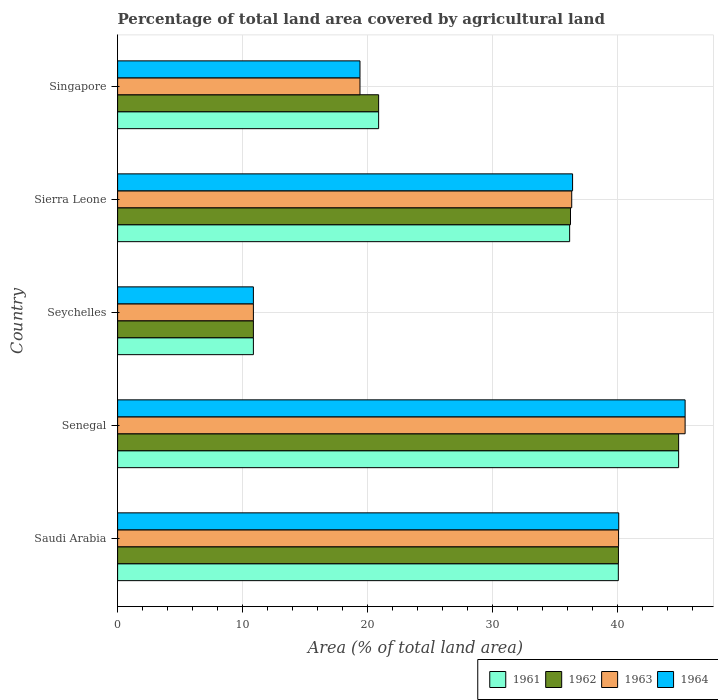How many different coloured bars are there?
Keep it short and to the point. 4. How many groups of bars are there?
Offer a terse response. 5. How many bars are there on the 2nd tick from the top?
Give a very brief answer. 4. How many bars are there on the 1st tick from the bottom?
Make the answer very short. 4. What is the label of the 5th group of bars from the top?
Provide a succinct answer. Saudi Arabia. In how many cases, is the number of bars for a given country not equal to the number of legend labels?
Give a very brief answer. 0. What is the percentage of agricultural land in 1961 in Senegal?
Keep it short and to the point. 44.91. Across all countries, what is the maximum percentage of agricultural land in 1964?
Keep it short and to the point. 45.43. Across all countries, what is the minimum percentage of agricultural land in 1964?
Ensure brevity in your answer.  10.87. In which country was the percentage of agricultural land in 1962 maximum?
Keep it short and to the point. Senegal. In which country was the percentage of agricultural land in 1964 minimum?
Offer a very short reply. Seychelles. What is the total percentage of agricultural land in 1962 in the graph?
Your response must be concise. 153.03. What is the difference between the percentage of agricultural land in 1962 in Seychelles and that in Sierra Leone?
Make the answer very short. -25.39. What is the difference between the percentage of agricultural land in 1964 in Senegal and the percentage of agricultural land in 1962 in Singapore?
Provide a short and direct response. 24.54. What is the average percentage of agricultural land in 1962 per country?
Keep it short and to the point. 30.61. What is the difference between the percentage of agricultural land in 1964 and percentage of agricultural land in 1963 in Saudi Arabia?
Provide a succinct answer. 0.01. In how many countries, is the percentage of agricultural land in 1962 greater than 2 %?
Make the answer very short. 5. What is the ratio of the percentage of agricultural land in 1962 in Seychelles to that in Singapore?
Keep it short and to the point. 0.52. Is the difference between the percentage of agricultural land in 1964 in Seychelles and Sierra Leone greater than the difference between the percentage of agricultural land in 1963 in Seychelles and Sierra Leone?
Make the answer very short. No. What is the difference between the highest and the second highest percentage of agricultural land in 1961?
Ensure brevity in your answer.  4.83. What is the difference between the highest and the lowest percentage of agricultural land in 1961?
Give a very brief answer. 34.04. Is the sum of the percentage of agricultural land in 1964 in Seychelles and Sierra Leone greater than the maximum percentage of agricultural land in 1963 across all countries?
Your answer should be compact. Yes. Is it the case that in every country, the sum of the percentage of agricultural land in 1964 and percentage of agricultural land in 1963 is greater than the sum of percentage of agricultural land in 1961 and percentage of agricultural land in 1962?
Offer a terse response. No. What does the 1st bar from the top in Sierra Leone represents?
Ensure brevity in your answer.  1964. How many bars are there?
Provide a succinct answer. 20. Are all the bars in the graph horizontal?
Your answer should be compact. Yes. How many countries are there in the graph?
Provide a succinct answer. 5. Are the values on the major ticks of X-axis written in scientific E-notation?
Ensure brevity in your answer.  No. Does the graph contain grids?
Ensure brevity in your answer.  Yes. What is the title of the graph?
Your answer should be very brief. Percentage of total land area covered by agricultural land. Does "1970" appear as one of the legend labels in the graph?
Your answer should be compact. No. What is the label or title of the X-axis?
Your answer should be compact. Area (% of total land area). What is the label or title of the Y-axis?
Make the answer very short. Country. What is the Area (% of total land area) in 1961 in Saudi Arabia?
Make the answer very short. 40.08. What is the Area (% of total land area) in 1962 in Saudi Arabia?
Make the answer very short. 40.09. What is the Area (% of total land area) of 1963 in Saudi Arabia?
Give a very brief answer. 40.1. What is the Area (% of total land area) in 1964 in Saudi Arabia?
Your response must be concise. 40.12. What is the Area (% of total land area) of 1961 in Senegal?
Keep it short and to the point. 44.91. What is the Area (% of total land area) in 1962 in Senegal?
Your answer should be very brief. 44.91. What is the Area (% of total land area) of 1963 in Senegal?
Your answer should be compact. 45.43. What is the Area (% of total land area) in 1964 in Senegal?
Offer a very short reply. 45.43. What is the Area (% of total land area) in 1961 in Seychelles?
Provide a short and direct response. 10.87. What is the Area (% of total land area) in 1962 in Seychelles?
Provide a succinct answer. 10.87. What is the Area (% of total land area) in 1963 in Seychelles?
Your answer should be compact. 10.87. What is the Area (% of total land area) of 1964 in Seychelles?
Provide a short and direct response. 10.87. What is the Area (% of total land area) in 1961 in Sierra Leone?
Your answer should be compact. 36.19. What is the Area (% of total land area) in 1962 in Sierra Leone?
Your response must be concise. 36.26. What is the Area (% of total land area) in 1963 in Sierra Leone?
Your answer should be very brief. 36.35. What is the Area (% of total land area) of 1964 in Sierra Leone?
Your response must be concise. 36.42. What is the Area (% of total land area) in 1961 in Singapore?
Give a very brief answer. 20.9. What is the Area (% of total land area) in 1962 in Singapore?
Ensure brevity in your answer.  20.9. What is the Area (% of total land area) of 1963 in Singapore?
Provide a short and direct response. 19.4. What is the Area (% of total land area) in 1964 in Singapore?
Provide a short and direct response. 19.4. Across all countries, what is the maximum Area (% of total land area) in 1961?
Provide a succinct answer. 44.91. Across all countries, what is the maximum Area (% of total land area) of 1962?
Make the answer very short. 44.91. Across all countries, what is the maximum Area (% of total land area) in 1963?
Your answer should be compact. 45.43. Across all countries, what is the maximum Area (% of total land area) of 1964?
Offer a very short reply. 45.43. Across all countries, what is the minimum Area (% of total land area) of 1961?
Keep it short and to the point. 10.87. Across all countries, what is the minimum Area (% of total land area) in 1962?
Provide a short and direct response. 10.87. Across all countries, what is the minimum Area (% of total land area) of 1963?
Ensure brevity in your answer.  10.87. Across all countries, what is the minimum Area (% of total land area) in 1964?
Make the answer very short. 10.87. What is the total Area (% of total land area) in 1961 in the graph?
Offer a very short reply. 152.95. What is the total Area (% of total land area) of 1962 in the graph?
Your answer should be compact. 153.03. What is the total Area (% of total land area) in 1963 in the graph?
Provide a short and direct response. 152.16. What is the total Area (% of total land area) in 1964 in the graph?
Offer a very short reply. 152.25. What is the difference between the Area (% of total land area) in 1961 in Saudi Arabia and that in Senegal?
Make the answer very short. -4.83. What is the difference between the Area (% of total land area) in 1962 in Saudi Arabia and that in Senegal?
Give a very brief answer. -4.82. What is the difference between the Area (% of total land area) in 1963 in Saudi Arabia and that in Senegal?
Offer a terse response. -5.33. What is the difference between the Area (% of total land area) in 1964 in Saudi Arabia and that in Senegal?
Provide a short and direct response. -5.31. What is the difference between the Area (% of total land area) of 1961 in Saudi Arabia and that in Seychelles?
Provide a succinct answer. 29.22. What is the difference between the Area (% of total land area) in 1962 in Saudi Arabia and that in Seychelles?
Provide a succinct answer. 29.22. What is the difference between the Area (% of total land area) of 1963 in Saudi Arabia and that in Seychelles?
Your response must be concise. 29.23. What is the difference between the Area (% of total land area) of 1964 in Saudi Arabia and that in Seychelles?
Offer a terse response. 29.25. What is the difference between the Area (% of total land area) in 1961 in Saudi Arabia and that in Sierra Leone?
Your response must be concise. 3.9. What is the difference between the Area (% of total land area) of 1962 in Saudi Arabia and that in Sierra Leone?
Provide a short and direct response. 3.84. What is the difference between the Area (% of total land area) of 1963 in Saudi Arabia and that in Sierra Leone?
Make the answer very short. 3.75. What is the difference between the Area (% of total land area) of 1964 in Saudi Arabia and that in Sierra Leone?
Your answer should be compact. 3.69. What is the difference between the Area (% of total land area) of 1961 in Saudi Arabia and that in Singapore?
Offer a very short reply. 19.19. What is the difference between the Area (% of total land area) of 1962 in Saudi Arabia and that in Singapore?
Ensure brevity in your answer.  19.2. What is the difference between the Area (% of total land area) of 1963 in Saudi Arabia and that in Singapore?
Make the answer very short. 20.7. What is the difference between the Area (% of total land area) of 1964 in Saudi Arabia and that in Singapore?
Offer a very short reply. 20.71. What is the difference between the Area (% of total land area) of 1961 in Senegal and that in Seychelles?
Provide a succinct answer. 34.04. What is the difference between the Area (% of total land area) in 1962 in Senegal and that in Seychelles?
Your answer should be compact. 34.04. What is the difference between the Area (% of total land area) of 1963 in Senegal and that in Seychelles?
Your answer should be compact. 34.56. What is the difference between the Area (% of total land area) in 1964 in Senegal and that in Seychelles?
Give a very brief answer. 34.56. What is the difference between the Area (% of total land area) of 1961 in Senegal and that in Sierra Leone?
Your answer should be compact. 8.73. What is the difference between the Area (% of total land area) in 1962 in Senegal and that in Sierra Leone?
Make the answer very short. 8.66. What is the difference between the Area (% of total land area) in 1963 in Senegal and that in Sierra Leone?
Provide a short and direct response. 9.08. What is the difference between the Area (% of total land area) in 1964 in Senegal and that in Sierra Leone?
Offer a very short reply. 9.01. What is the difference between the Area (% of total land area) of 1961 in Senegal and that in Singapore?
Your response must be concise. 24.02. What is the difference between the Area (% of total land area) in 1962 in Senegal and that in Singapore?
Offer a terse response. 24.02. What is the difference between the Area (% of total land area) in 1963 in Senegal and that in Singapore?
Your answer should be compact. 26.03. What is the difference between the Area (% of total land area) in 1964 in Senegal and that in Singapore?
Give a very brief answer. 26.03. What is the difference between the Area (% of total land area) in 1961 in Seychelles and that in Sierra Leone?
Your answer should be very brief. -25.32. What is the difference between the Area (% of total land area) of 1962 in Seychelles and that in Sierra Leone?
Your answer should be very brief. -25.39. What is the difference between the Area (% of total land area) of 1963 in Seychelles and that in Sierra Leone?
Keep it short and to the point. -25.48. What is the difference between the Area (% of total land area) of 1964 in Seychelles and that in Sierra Leone?
Keep it short and to the point. -25.55. What is the difference between the Area (% of total land area) of 1961 in Seychelles and that in Singapore?
Offer a terse response. -10.03. What is the difference between the Area (% of total land area) of 1962 in Seychelles and that in Singapore?
Your answer should be compact. -10.03. What is the difference between the Area (% of total land area) in 1963 in Seychelles and that in Singapore?
Offer a very short reply. -8.53. What is the difference between the Area (% of total land area) of 1964 in Seychelles and that in Singapore?
Ensure brevity in your answer.  -8.53. What is the difference between the Area (% of total land area) in 1961 in Sierra Leone and that in Singapore?
Keep it short and to the point. 15.29. What is the difference between the Area (% of total land area) of 1962 in Sierra Leone and that in Singapore?
Provide a short and direct response. 15.36. What is the difference between the Area (% of total land area) in 1963 in Sierra Leone and that in Singapore?
Give a very brief answer. 16.95. What is the difference between the Area (% of total land area) of 1964 in Sierra Leone and that in Singapore?
Provide a short and direct response. 17.02. What is the difference between the Area (% of total land area) of 1961 in Saudi Arabia and the Area (% of total land area) of 1962 in Senegal?
Your response must be concise. -4.83. What is the difference between the Area (% of total land area) in 1961 in Saudi Arabia and the Area (% of total land area) in 1963 in Senegal?
Your answer should be very brief. -5.35. What is the difference between the Area (% of total land area) of 1961 in Saudi Arabia and the Area (% of total land area) of 1964 in Senegal?
Keep it short and to the point. -5.35. What is the difference between the Area (% of total land area) of 1962 in Saudi Arabia and the Area (% of total land area) of 1963 in Senegal?
Your answer should be compact. -5.34. What is the difference between the Area (% of total land area) in 1962 in Saudi Arabia and the Area (% of total land area) in 1964 in Senegal?
Your response must be concise. -5.34. What is the difference between the Area (% of total land area) of 1963 in Saudi Arabia and the Area (% of total land area) of 1964 in Senegal?
Ensure brevity in your answer.  -5.33. What is the difference between the Area (% of total land area) of 1961 in Saudi Arabia and the Area (% of total land area) of 1962 in Seychelles?
Your answer should be very brief. 29.22. What is the difference between the Area (% of total land area) in 1961 in Saudi Arabia and the Area (% of total land area) in 1963 in Seychelles?
Your answer should be compact. 29.22. What is the difference between the Area (% of total land area) in 1961 in Saudi Arabia and the Area (% of total land area) in 1964 in Seychelles?
Offer a very short reply. 29.22. What is the difference between the Area (% of total land area) of 1962 in Saudi Arabia and the Area (% of total land area) of 1963 in Seychelles?
Your response must be concise. 29.22. What is the difference between the Area (% of total land area) in 1962 in Saudi Arabia and the Area (% of total land area) in 1964 in Seychelles?
Give a very brief answer. 29.22. What is the difference between the Area (% of total land area) of 1963 in Saudi Arabia and the Area (% of total land area) of 1964 in Seychelles?
Give a very brief answer. 29.23. What is the difference between the Area (% of total land area) in 1961 in Saudi Arabia and the Area (% of total land area) in 1962 in Sierra Leone?
Your answer should be compact. 3.83. What is the difference between the Area (% of total land area) in 1961 in Saudi Arabia and the Area (% of total land area) in 1963 in Sierra Leone?
Give a very brief answer. 3.73. What is the difference between the Area (% of total land area) in 1961 in Saudi Arabia and the Area (% of total land area) in 1964 in Sierra Leone?
Your answer should be very brief. 3.66. What is the difference between the Area (% of total land area) in 1962 in Saudi Arabia and the Area (% of total land area) in 1963 in Sierra Leone?
Ensure brevity in your answer.  3.74. What is the difference between the Area (% of total land area) of 1962 in Saudi Arabia and the Area (% of total land area) of 1964 in Sierra Leone?
Ensure brevity in your answer.  3.67. What is the difference between the Area (% of total land area) in 1963 in Saudi Arabia and the Area (% of total land area) in 1964 in Sierra Leone?
Offer a terse response. 3.68. What is the difference between the Area (% of total land area) of 1961 in Saudi Arabia and the Area (% of total land area) of 1962 in Singapore?
Your answer should be compact. 19.19. What is the difference between the Area (% of total land area) of 1961 in Saudi Arabia and the Area (% of total land area) of 1963 in Singapore?
Keep it short and to the point. 20.68. What is the difference between the Area (% of total land area) of 1961 in Saudi Arabia and the Area (% of total land area) of 1964 in Singapore?
Provide a succinct answer. 20.68. What is the difference between the Area (% of total land area) in 1962 in Saudi Arabia and the Area (% of total land area) in 1963 in Singapore?
Provide a succinct answer. 20.69. What is the difference between the Area (% of total land area) in 1962 in Saudi Arabia and the Area (% of total land area) in 1964 in Singapore?
Make the answer very short. 20.69. What is the difference between the Area (% of total land area) of 1963 in Saudi Arabia and the Area (% of total land area) of 1964 in Singapore?
Your response must be concise. 20.7. What is the difference between the Area (% of total land area) of 1961 in Senegal and the Area (% of total land area) of 1962 in Seychelles?
Provide a short and direct response. 34.04. What is the difference between the Area (% of total land area) in 1961 in Senegal and the Area (% of total land area) in 1963 in Seychelles?
Ensure brevity in your answer.  34.04. What is the difference between the Area (% of total land area) in 1961 in Senegal and the Area (% of total land area) in 1964 in Seychelles?
Your response must be concise. 34.04. What is the difference between the Area (% of total land area) in 1962 in Senegal and the Area (% of total land area) in 1963 in Seychelles?
Keep it short and to the point. 34.04. What is the difference between the Area (% of total land area) of 1962 in Senegal and the Area (% of total land area) of 1964 in Seychelles?
Make the answer very short. 34.04. What is the difference between the Area (% of total land area) in 1963 in Senegal and the Area (% of total land area) in 1964 in Seychelles?
Your answer should be compact. 34.56. What is the difference between the Area (% of total land area) in 1961 in Senegal and the Area (% of total land area) in 1962 in Sierra Leone?
Provide a succinct answer. 8.66. What is the difference between the Area (% of total land area) in 1961 in Senegal and the Area (% of total land area) in 1963 in Sierra Leone?
Your answer should be compact. 8.56. What is the difference between the Area (% of total land area) of 1961 in Senegal and the Area (% of total land area) of 1964 in Sierra Leone?
Your response must be concise. 8.49. What is the difference between the Area (% of total land area) of 1962 in Senegal and the Area (% of total land area) of 1963 in Sierra Leone?
Your answer should be very brief. 8.56. What is the difference between the Area (% of total land area) of 1962 in Senegal and the Area (% of total land area) of 1964 in Sierra Leone?
Keep it short and to the point. 8.49. What is the difference between the Area (% of total land area) of 1963 in Senegal and the Area (% of total land area) of 1964 in Sierra Leone?
Your answer should be compact. 9.01. What is the difference between the Area (% of total land area) of 1961 in Senegal and the Area (% of total land area) of 1962 in Singapore?
Offer a very short reply. 24.02. What is the difference between the Area (% of total land area) in 1961 in Senegal and the Area (% of total land area) in 1963 in Singapore?
Ensure brevity in your answer.  25.51. What is the difference between the Area (% of total land area) of 1961 in Senegal and the Area (% of total land area) of 1964 in Singapore?
Offer a terse response. 25.51. What is the difference between the Area (% of total land area) of 1962 in Senegal and the Area (% of total land area) of 1963 in Singapore?
Provide a short and direct response. 25.51. What is the difference between the Area (% of total land area) of 1962 in Senegal and the Area (% of total land area) of 1964 in Singapore?
Provide a succinct answer. 25.51. What is the difference between the Area (% of total land area) in 1963 in Senegal and the Area (% of total land area) in 1964 in Singapore?
Provide a short and direct response. 26.03. What is the difference between the Area (% of total land area) of 1961 in Seychelles and the Area (% of total land area) of 1962 in Sierra Leone?
Your response must be concise. -25.39. What is the difference between the Area (% of total land area) of 1961 in Seychelles and the Area (% of total land area) of 1963 in Sierra Leone?
Provide a succinct answer. -25.48. What is the difference between the Area (% of total land area) of 1961 in Seychelles and the Area (% of total land area) of 1964 in Sierra Leone?
Offer a terse response. -25.55. What is the difference between the Area (% of total land area) in 1962 in Seychelles and the Area (% of total land area) in 1963 in Sierra Leone?
Your response must be concise. -25.48. What is the difference between the Area (% of total land area) in 1962 in Seychelles and the Area (% of total land area) in 1964 in Sierra Leone?
Offer a very short reply. -25.55. What is the difference between the Area (% of total land area) of 1963 in Seychelles and the Area (% of total land area) of 1964 in Sierra Leone?
Your answer should be very brief. -25.55. What is the difference between the Area (% of total land area) in 1961 in Seychelles and the Area (% of total land area) in 1962 in Singapore?
Your answer should be very brief. -10.03. What is the difference between the Area (% of total land area) of 1961 in Seychelles and the Area (% of total land area) of 1963 in Singapore?
Your answer should be very brief. -8.53. What is the difference between the Area (% of total land area) in 1961 in Seychelles and the Area (% of total land area) in 1964 in Singapore?
Keep it short and to the point. -8.53. What is the difference between the Area (% of total land area) in 1962 in Seychelles and the Area (% of total land area) in 1963 in Singapore?
Provide a succinct answer. -8.53. What is the difference between the Area (% of total land area) of 1962 in Seychelles and the Area (% of total land area) of 1964 in Singapore?
Keep it short and to the point. -8.53. What is the difference between the Area (% of total land area) of 1963 in Seychelles and the Area (% of total land area) of 1964 in Singapore?
Make the answer very short. -8.53. What is the difference between the Area (% of total land area) of 1961 in Sierra Leone and the Area (% of total land area) of 1962 in Singapore?
Provide a succinct answer. 15.29. What is the difference between the Area (% of total land area) in 1961 in Sierra Leone and the Area (% of total land area) in 1963 in Singapore?
Provide a short and direct response. 16.78. What is the difference between the Area (% of total land area) in 1961 in Sierra Leone and the Area (% of total land area) in 1964 in Singapore?
Offer a very short reply. 16.78. What is the difference between the Area (% of total land area) in 1962 in Sierra Leone and the Area (% of total land area) in 1963 in Singapore?
Provide a short and direct response. 16.85. What is the difference between the Area (% of total land area) of 1962 in Sierra Leone and the Area (% of total land area) of 1964 in Singapore?
Your answer should be compact. 16.85. What is the difference between the Area (% of total land area) of 1963 in Sierra Leone and the Area (% of total land area) of 1964 in Singapore?
Provide a short and direct response. 16.95. What is the average Area (% of total land area) in 1961 per country?
Provide a short and direct response. 30.59. What is the average Area (% of total land area) of 1962 per country?
Your response must be concise. 30.61. What is the average Area (% of total land area) in 1963 per country?
Make the answer very short. 30.43. What is the average Area (% of total land area) of 1964 per country?
Your answer should be very brief. 30.45. What is the difference between the Area (% of total land area) in 1961 and Area (% of total land area) in 1962 in Saudi Arabia?
Ensure brevity in your answer.  -0.01. What is the difference between the Area (% of total land area) in 1961 and Area (% of total land area) in 1963 in Saudi Arabia?
Your response must be concise. -0.02. What is the difference between the Area (% of total land area) of 1961 and Area (% of total land area) of 1964 in Saudi Arabia?
Provide a succinct answer. -0.03. What is the difference between the Area (% of total land area) of 1962 and Area (% of total land area) of 1963 in Saudi Arabia?
Give a very brief answer. -0.01. What is the difference between the Area (% of total land area) in 1962 and Area (% of total land area) in 1964 in Saudi Arabia?
Give a very brief answer. -0.02. What is the difference between the Area (% of total land area) in 1963 and Area (% of total land area) in 1964 in Saudi Arabia?
Ensure brevity in your answer.  -0.01. What is the difference between the Area (% of total land area) of 1961 and Area (% of total land area) of 1963 in Senegal?
Provide a short and direct response. -0.52. What is the difference between the Area (% of total land area) in 1961 and Area (% of total land area) in 1964 in Senegal?
Make the answer very short. -0.52. What is the difference between the Area (% of total land area) of 1962 and Area (% of total land area) of 1963 in Senegal?
Make the answer very short. -0.52. What is the difference between the Area (% of total land area) of 1962 and Area (% of total land area) of 1964 in Senegal?
Offer a terse response. -0.52. What is the difference between the Area (% of total land area) of 1961 and Area (% of total land area) of 1962 in Seychelles?
Make the answer very short. 0. What is the difference between the Area (% of total land area) of 1962 and Area (% of total land area) of 1963 in Seychelles?
Make the answer very short. 0. What is the difference between the Area (% of total land area) of 1962 and Area (% of total land area) of 1964 in Seychelles?
Provide a short and direct response. 0. What is the difference between the Area (% of total land area) in 1963 and Area (% of total land area) in 1964 in Seychelles?
Your answer should be very brief. 0. What is the difference between the Area (% of total land area) of 1961 and Area (% of total land area) of 1962 in Sierra Leone?
Provide a succinct answer. -0.07. What is the difference between the Area (% of total land area) in 1961 and Area (% of total land area) in 1963 in Sierra Leone?
Ensure brevity in your answer.  -0.17. What is the difference between the Area (% of total land area) of 1961 and Area (% of total land area) of 1964 in Sierra Leone?
Your answer should be very brief. -0.24. What is the difference between the Area (% of total land area) in 1962 and Area (% of total land area) in 1963 in Sierra Leone?
Provide a succinct answer. -0.1. What is the difference between the Area (% of total land area) of 1962 and Area (% of total land area) of 1964 in Sierra Leone?
Make the answer very short. -0.17. What is the difference between the Area (% of total land area) of 1963 and Area (% of total land area) of 1964 in Sierra Leone?
Your answer should be compact. -0.07. What is the difference between the Area (% of total land area) of 1961 and Area (% of total land area) of 1962 in Singapore?
Your answer should be very brief. 0. What is the difference between the Area (% of total land area) of 1961 and Area (% of total land area) of 1963 in Singapore?
Your response must be concise. 1.49. What is the difference between the Area (% of total land area) in 1961 and Area (% of total land area) in 1964 in Singapore?
Offer a terse response. 1.49. What is the difference between the Area (% of total land area) of 1962 and Area (% of total land area) of 1963 in Singapore?
Provide a short and direct response. 1.49. What is the difference between the Area (% of total land area) of 1962 and Area (% of total land area) of 1964 in Singapore?
Provide a short and direct response. 1.49. What is the ratio of the Area (% of total land area) in 1961 in Saudi Arabia to that in Senegal?
Give a very brief answer. 0.89. What is the ratio of the Area (% of total land area) in 1962 in Saudi Arabia to that in Senegal?
Make the answer very short. 0.89. What is the ratio of the Area (% of total land area) in 1963 in Saudi Arabia to that in Senegal?
Keep it short and to the point. 0.88. What is the ratio of the Area (% of total land area) of 1964 in Saudi Arabia to that in Senegal?
Make the answer very short. 0.88. What is the ratio of the Area (% of total land area) in 1961 in Saudi Arabia to that in Seychelles?
Provide a succinct answer. 3.69. What is the ratio of the Area (% of total land area) of 1962 in Saudi Arabia to that in Seychelles?
Provide a succinct answer. 3.69. What is the ratio of the Area (% of total land area) in 1963 in Saudi Arabia to that in Seychelles?
Keep it short and to the point. 3.69. What is the ratio of the Area (% of total land area) in 1964 in Saudi Arabia to that in Seychelles?
Ensure brevity in your answer.  3.69. What is the ratio of the Area (% of total land area) of 1961 in Saudi Arabia to that in Sierra Leone?
Offer a very short reply. 1.11. What is the ratio of the Area (% of total land area) in 1962 in Saudi Arabia to that in Sierra Leone?
Your answer should be very brief. 1.11. What is the ratio of the Area (% of total land area) of 1963 in Saudi Arabia to that in Sierra Leone?
Offer a terse response. 1.1. What is the ratio of the Area (% of total land area) in 1964 in Saudi Arabia to that in Sierra Leone?
Ensure brevity in your answer.  1.1. What is the ratio of the Area (% of total land area) of 1961 in Saudi Arabia to that in Singapore?
Ensure brevity in your answer.  1.92. What is the ratio of the Area (% of total land area) in 1962 in Saudi Arabia to that in Singapore?
Offer a very short reply. 1.92. What is the ratio of the Area (% of total land area) in 1963 in Saudi Arabia to that in Singapore?
Provide a short and direct response. 2.07. What is the ratio of the Area (% of total land area) of 1964 in Saudi Arabia to that in Singapore?
Provide a succinct answer. 2.07. What is the ratio of the Area (% of total land area) in 1961 in Senegal to that in Seychelles?
Keep it short and to the point. 4.13. What is the ratio of the Area (% of total land area) of 1962 in Senegal to that in Seychelles?
Your answer should be very brief. 4.13. What is the ratio of the Area (% of total land area) in 1963 in Senegal to that in Seychelles?
Ensure brevity in your answer.  4.18. What is the ratio of the Area (% of total land area) of 1964 in Senegal to that in Seychelles?
Ensure brevity in your answer.  4.18. What is the ratio of the Area (% of total land area) of 1961 in Senegal to that in Sierra Leone?
Provide a short and direct response. 1.24. What is the ratio of the Area (% of total land area) of 1962 in Senegal to that in Sierra Leone?
Offer a very short reply. 1.24. What is the ratio of the Area (% of total land area) of 1963 in Senegal to that in Sierra Leone?
Provide a short and direct response. 1.25. What is the ratio of the Area (% of total land area) of 1964 in Senegal to that in Sierra Leone?
Give a very brief answer. 1.25. What is the ratio of the Area (% of total land area) in 1961 in Senegal to that in Singapore?
Ensure brevity in your answer.  2.15. What is the ratio of the Area (% of total land area) of 1962 in Senegal to that in Singapore?
Provide a short and direct response. 2.15. What is the ratio of the Area (% of total land area) of 1963 in Senegal to that in Singapore?
Offer a terse response. 2.34. What is the ratio of the Area (% of total land area) in 1964 in Senegal to that in Singapore?
Make the answer very short. 2.34. What is the ratio of the Area (% of total land area) in 1961 in Seychelles to that in Sierra Leone?
Offer a very short reply. 0.3. What is the ratio of the Area (% of total land area) of 1962 in Seychelles to that in Sierra Leone?
Keep it short and to the point. 0.3. What is the ratio of the Area (% of total land area) in 1963 in Seychelles to that in Sierra Leone?
Make the answer very short. 0.3. What is the ratio of the Area (% of total land area) of 1964 in Seychelles to that in Sierra Leone?
Provide a short and direct response. 0.3. What is the ratio of the Area (% of total land area) of 1961 in Seychelles to that in Singapore?
Keep it short and to the point. 0.52. What is the ratio of the Area (% of total land area) in 1962 in Seychelles to that in Singapore?
Keep it short and to the point. 0.52. What is the ratio of the Area (% of total land area) in 1963 in Seychelles to that in Singapore?
Provide a short and direct response. 0.56. What is the ratio of the Area (% of total land area) in 1964 in Seychelles to that in Singapore?
Your answer should be compact. 0.56. What is the ratio of the Area (% of total land area) in 1961 in Sierra Leone to that in Singapore?
Offer a terse response. 1.73. What is the ratio of the Area (% of total land area) of 1962 in Sierra Leone to that in Singapore?
Provide a succinct answer. 1.74. What is the ratio of the Area (% of total land area) of 1963 in Sierra Leone to that in Singapore?
Ensure brevity in your answer.  1.87. What is the ratio of the Area (% of total land area) in 1964 in Sierra Leone to that in Singapore?
Ensure brevity in your answer.  1.88. What is the difference between the highest and the second highest Area (% of total land area) in 1961?
Your response must be concise. 4.83. What is the difference between the highest and the second highest Area (% of total land area) in 1962?
Keep it short and to the point. 4.82. What is the difference between the highest and the second highest Area (% of total land area) in 1963?
Make the answer very short. 5.33. What is the difference between the highest and the second highest Area (% of total land area) of 1964?
Give a very brief answer. 5.31. What is the difference between the highest and the lowest Area (% of total land area) of 1961?
Offer a very short reply. 34.04. What is the difference between the highest and the lowest Area (% of total land area) in 1962?
Keep it short and to the point. 34.04. What is the difference between the highest and the lowest Area (% of total land area) in 1963?
Provide a short and direct response. 34.56. What is the difference between the highest and the lowest Area (% of total land area) in 1964?
Your answer should be very brief. 34.56. 